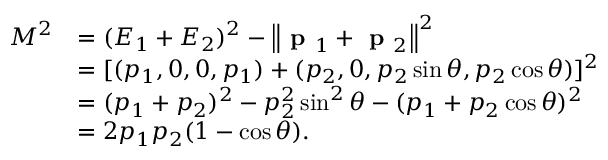<formula> <loc_0><loc_0><loc_500><loc_500>{ \begin{array} { r l } { M ^ { 2 } } & { = ( E _ { 1 } + E _ { 2 } ) ^ { 2 } - \left \| { p } _ { 1 } + { p } _ { 2 } \right \| ^ { 2 } } \\ & { = [ ( p _ { 1 } , 0 , 0 , p _ { 1 } ) + ( p _ { 2 } , 0 , p _ { 2 } \sin \theta , p _ { 2 } \cos \theta ) ] ^ { 2 } } \\ & { = ( p _ { 1 } + p _ { 2 } ) ^ { 2 } - p _ { 2 } ^ { 2 } \sin ^ { 2 } \theta - ( p _ { 1 } + p _ { 2 } \cos \theta ) ^ { 2 } } \\ & { = 2 p _ { 1 } p _ { 2 } ( 1 - \cos \theta ) . } \end{array} }</formula> 